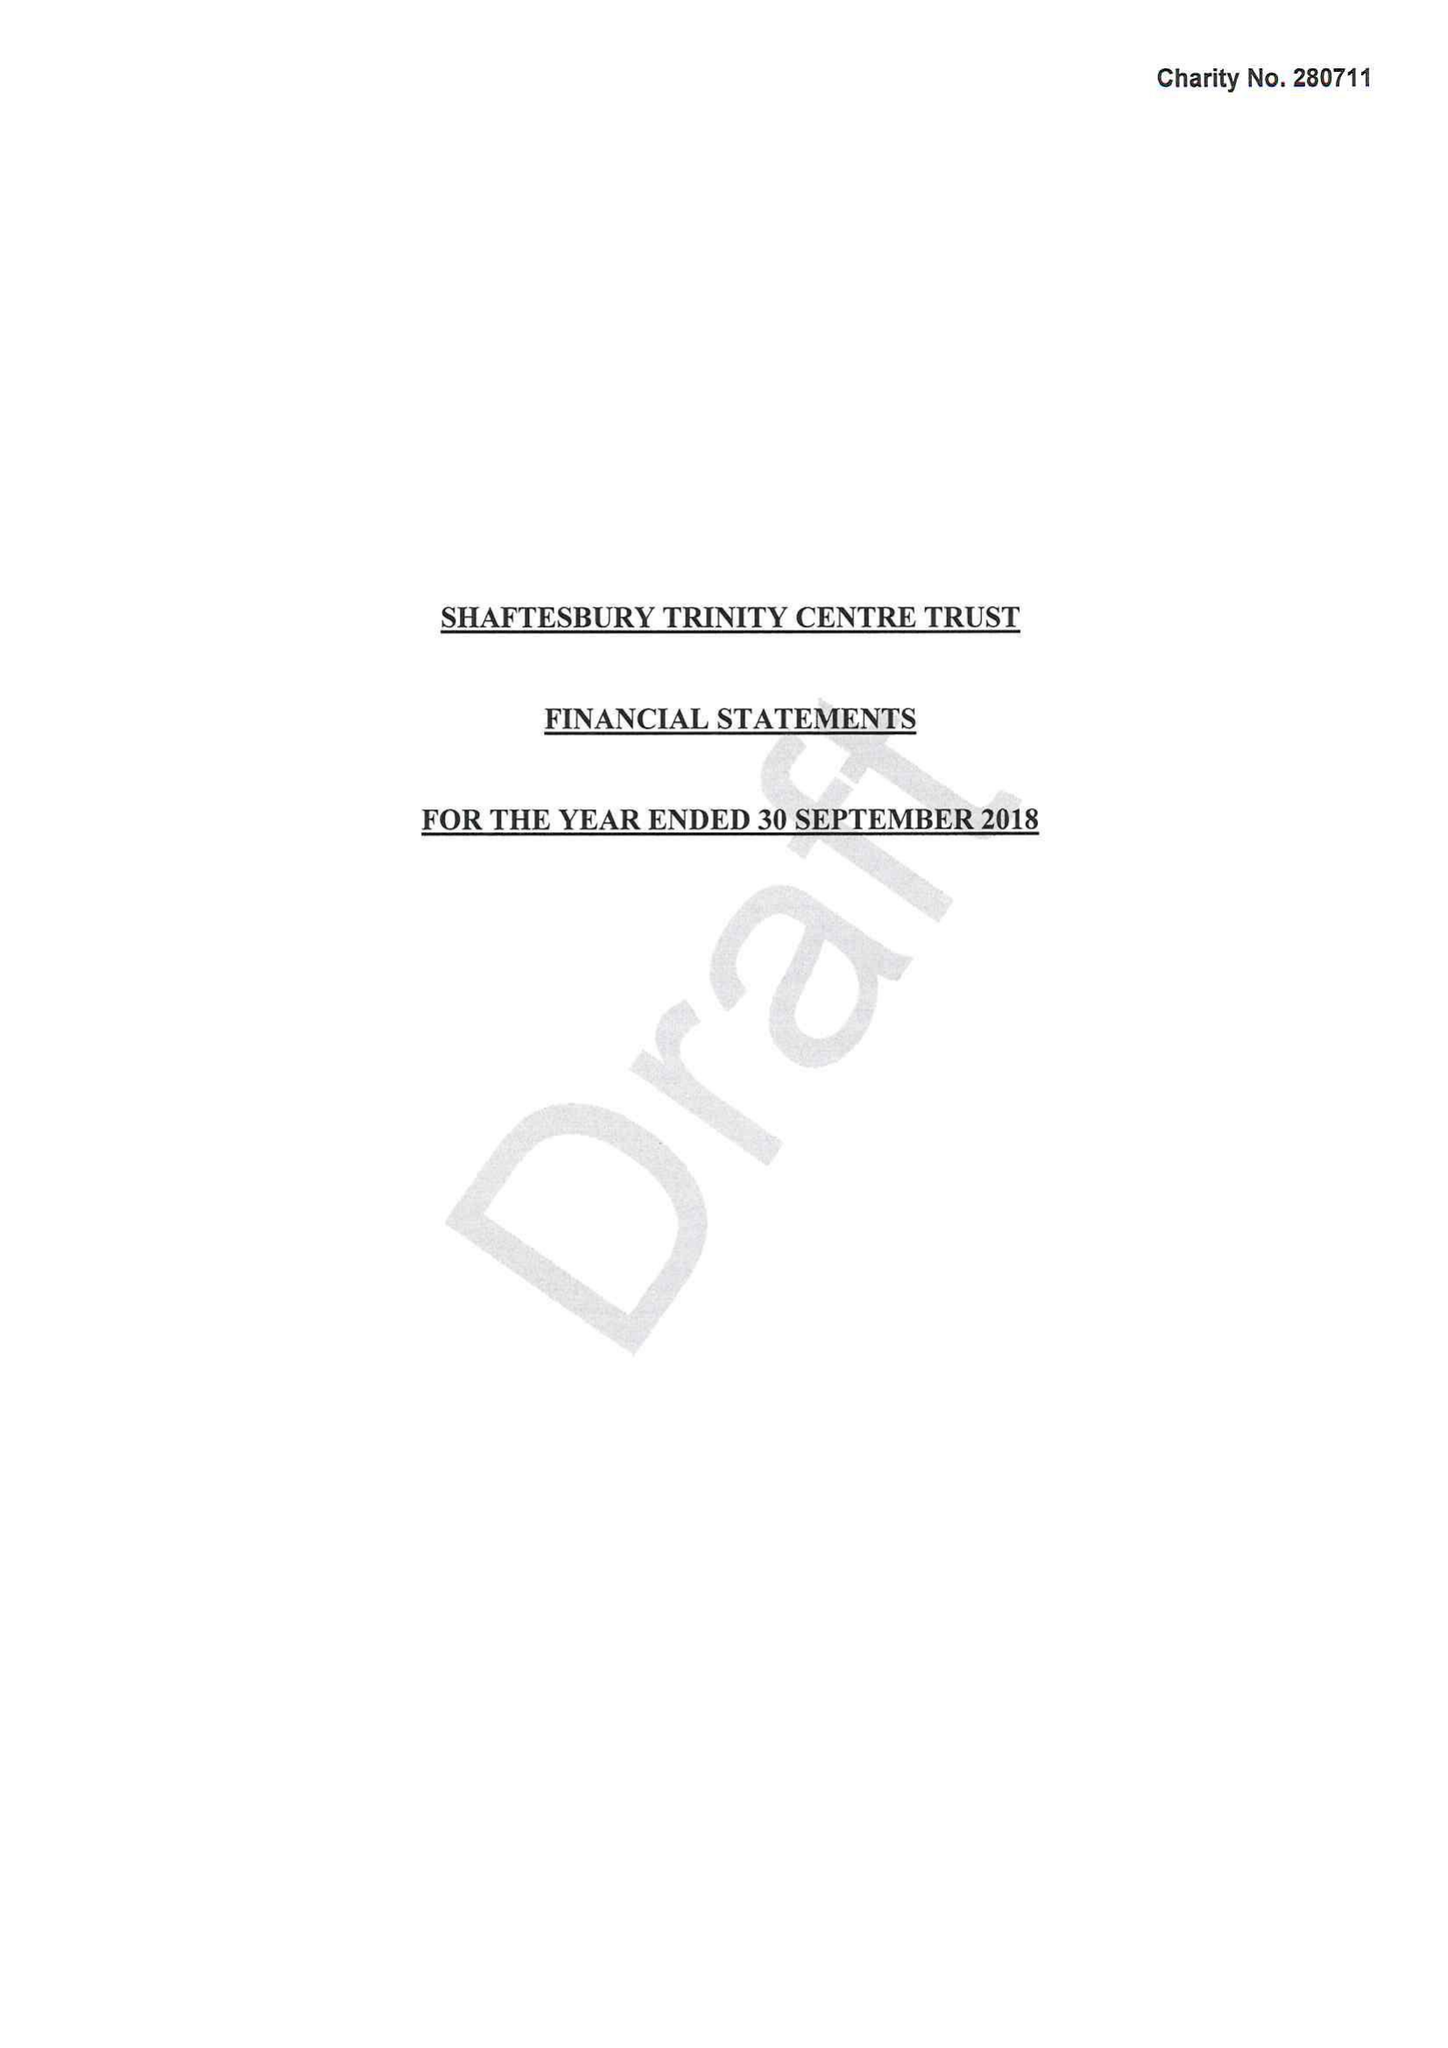What is the value for the address__street_line?
Answer the question using a single word or phrase. None 